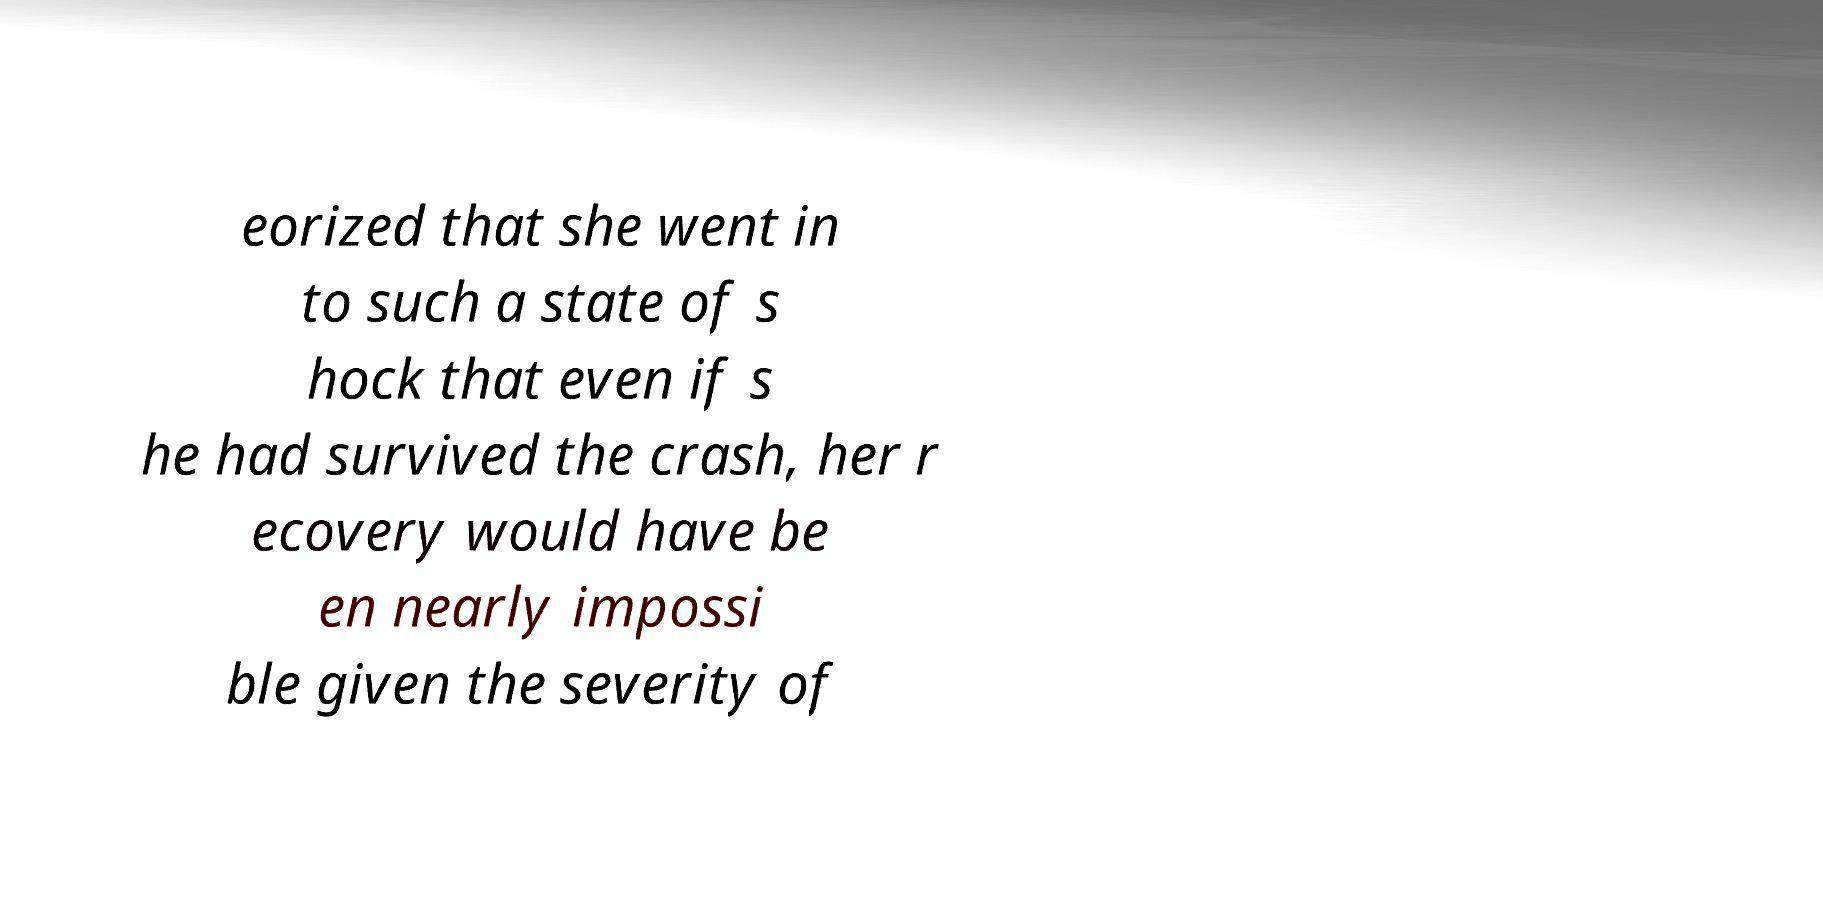Please read and relay the text visible in this image. What does it say? eorized that she went in to such a state of s hock that even if s he had survived the crash, her r ecovery would have be en nearly impossi ble given the severity of 